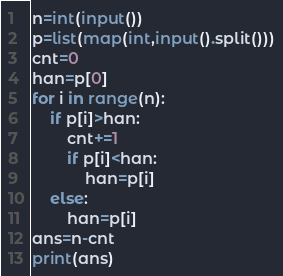<code> <loc_0><loc_0><loc_500><loc_500><_Python_>n=int(input())
p=list(map(int,input().split()))
cnt=0
han=p[0]
for i in range(n):
    if p[i]>han:
        cnt+=1
        if p[i]<han:
            han=p[i]
    else:
        han=p[i]
ans=n-cnt
print(ans)</code> 